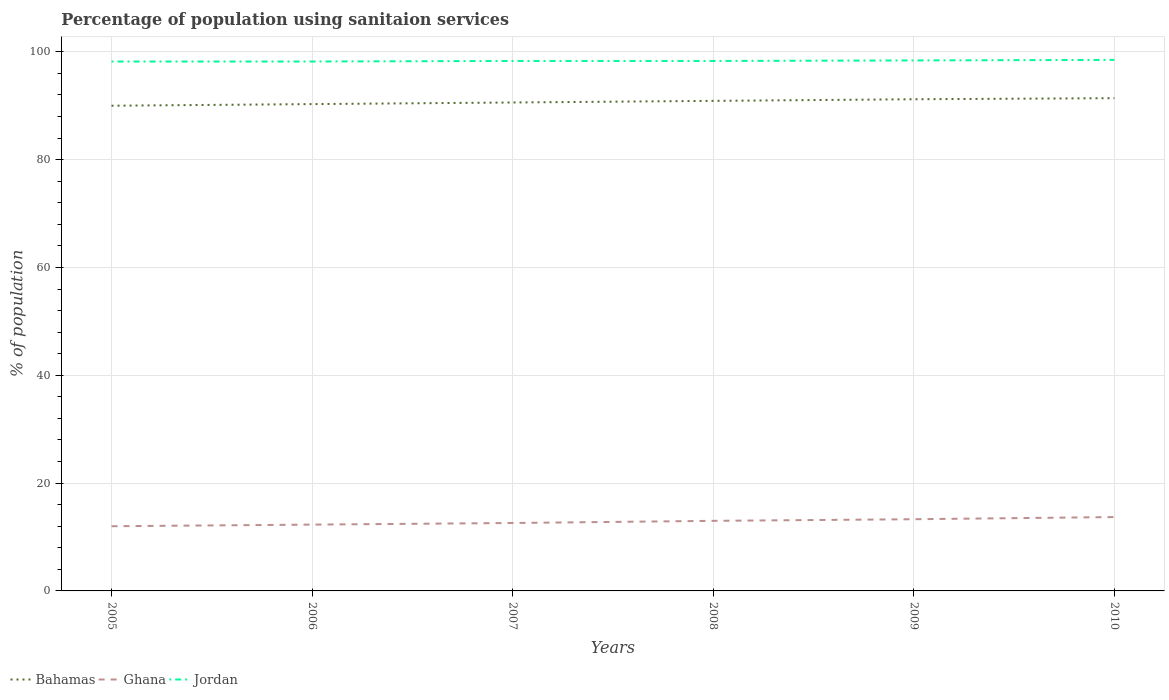Across all years, what is the maximum percentage of population using sanitaion services in Bahamas?
Give a very brief answer. 90. In which year was the percentage of population using sanitaion services in Ghana maximum?
Offer a terse response. 2005. What is the total percentage of population using sanitaion services in Bahamas in the graph?
Your answer should be compact. -0.6. What is the difference between the highest and the second highest percentage of population using sanitaion services in Ghana?
Provide a succinct answer. 1.7. What is the difference between the highest and the lowest percentage of population using sanitaion services in Jordan?
Offer a terse response. 2. Is the percentage of population using sanitaion services in Bahamas strictly greater than the percentage of population using sanitaion services in Ghana over the years?
Offer a terse response. No. What is the difference between two consecutive major ticks on the Y-axis?
Give a very brief answer. 20. Does the graph contain any zero values?
Ensure brevity in your answer.  No. Does the graph contain grids?
Make the answer very short. Yes. Where does the legend appear in the graph?
Your answer should be very brief. Bottom left. What is the title of the graph?
Your response must be concise. Percentage of population using sanitaion services. Does "Fiji" appear as one of the legend labels in the graph?
Ensure brevity in your answer.  No. What is the label or title of the Y-axis?
Your answer should be compact. % of population. What is the % of population of Ghana in 2005?
Offer a very short reply. 12. What is the % of population in Jordan in 2005?
Your answer should be compact. 98.2. What is the % of population of Bahamas in 2006?
Provide a succinct answer. 90.3. What is the % of population in Ghana in 2006?
Offer a terse response. 12.3. What is the % of population of Jordan in 2006?
Your answer should be compact. 98.2. What is the % of population in Bahamas in 2007?
Provide a succinct answer. 90.6. What is the % of population of Ghana in 2007?
Give a very brief answer. 12.6. What is the % of population in Jordan in 2007?
Keep it short and to the point. 98.3. What is the % of population in Bahamas in 2008?
Ensure brevity in your answer.  90.9. What is the % of population in Ghana in 2008?
Keep it short and to the point. 13. What is the % of population of Jordan in 2008?
Make the answer very short. 98.3. What is the % of population of Bahamas in 2009?
Your answer should be compact. 91.2. What is the % of population in Jordan in 2009?
Provide a short and direct response. 98.4. What is the % of population in Bahamas in 2010?
Keep it short and to the point. 91.4. What is the % of population in Jordan in 2010?
Keep it short and to the point. 98.5. Across all years, what is the maximum % of population of Bahamas?
Offer a very short reply. 91.4. Across all years, what is the maximum % of population in Jordan?
Provide a succinct answer. 98.5. Across all years, what is the minimum % of population of Ghana?
Give a very brief answer. 12. Across all years, what is the minimum % of population of Jordan?
Your answer should be very brief. 98.2. What is the total % of population in Bahamas in the graph?
Offer a very short reply. 544.4. What is the total % of population in Ghana in the graph?
Keep it short and to the point. 76.9. What is the total % of population in Jordan in the graph?
Make the answer very short. 589.9. What is the difference between the % of population of Bahamas in 2005 and that in 2006?
Offer a terse response. -0.3. What is the difference between the % of population in Ghana in 2005 and that in 2006?
Your answer should be very brief. -0.3. What is the difference between the % of population of Jordan in 2005 and that in 2006?
Ensure brevity in your answer.  0. What is the difference between the % of population of Bahamas in 2005 and that in 2007?
Provide a short and direct response. -0.6. What is the difference between the % of population of Ghana in 2005 and that in 2007?
Offer a terse response. -0.6. What is the difference between the % of population in Jordan in 2005 and that in 2007?
Your answer should be compact. -0.1. What is the difference between the % of population in Ghana in 2005 and that in 2008?
Ensure brevity in your answer.  -1. What is the difference between the % of population of Jordan in 2005 and that in 2008?
Your answer should be very brief. -0.1. What is the difference between the % of population in Bahamas in 2005 and that in 2009?
Your response must be concise. -1.2. What is the difference between the % of population in Jordan in 2005 and that in 2009?
Provide a succinct answer. -0.2. What is the difference between the % of population in Ghana in 2005 and that in 2010?
Ensure brevity in your answer.  -1.7. What is the difference between the % of population in Jordan in 2005 and that in 2010?
Ensure brevity in your answer.  -0.3. What is the difference between the % of population of Ghana in 2006 and that in 2007?
Offer a terse response. -0.3. What is the difference between the % of population in Jordan in 2006 and that in 2007?
Give a very brief answer. -0.1. What is the difference between the % of population in Jordan in 2006 and that in 2008?
Keep it short and to the point. -0.1. What is the difference between the % of population in Ghana in 2006 and that in 2009?
Provide a succinct answer. -1. What is the difference between the % of population of Ghana in 2006 and that in 2010?
Your answer should be very brief. -1.4. What is the difference between the % of population of Bahamas in 2007 and that in 2008?
Provide a short and direct response. -0.3. What is the difference between the % of population of Jordan in 2007 and that in 2008?
Keep it short and to the point. 0. What is the difference between the % of population of Ghana in 2007 and that in 2009?
Give a very brief answer. -0.7. What is the difference between the % of population of Jordan in 2007 and that in 2009?
Ensure brevity in your answer.  -0.1. What is the difference between the % of population in Jordan in 2008 and that in 2010?
Provide a succinct answer. -0.2. What is the difference between the % of population in Bahamas in 2005 and the % of population in Ghana in 2006?
Your response must be concise. 77.7. What is the difference between the % of population in Bahamas in 2005 and the % of population in Jordan in 2006?
Give a very brief answer. -8.2. What is the difference between the % of population in Ghana in 2005 and the % of population in Jordan in 2006?
Offer a terse response. -86.2. What is the difference between the % of population of Bahamas in 2005 and the % of population of Ghana in 2007?
Give a very brief answer. 77.4. What is the difference between the % of population in Bahamas in 2005 and the % of population in Jordan in 2007?
Make the answer very short. -8.3. What is the difference between the % of population in Ghana in 2005 and the % of population in Jordan in 2007?
Provide a succinct answer. -86.3. What is the difference between the % of population of Ghana in 2005 and the % of population of Jordan in 2008?
Your response must be concise. -86.3. What is the difference between the % of population of Bahamas in 2005 and the % of population of Ghana in 2009?
Give a very brief answer. 76.7. What is the difference between the % of population in Bahamas in 2005 and the % of population in Jordan in 2009?
Offer a very short reply. -8.4. What is the difference between the % of population of Ghana in 2005 and the % of population of Jordan in 2009?
Your answer should be compact. -86.4. What is the difference between the % of population of Bahamas in 2005 and the % of population of Ghana in 2010?
Ensure brevity in your answer.  76.3. What is the difference between the % of population of Bahamas in 2005 and the % of population of Jordan in 2010?
Your response must be concise. -8.5. What is the difference between the % of population in Ghana in 2005 and the % of population in Jordan in 2010?
Offer a very short reply. -86.5. What is the difference between the % of population in Bahamas in 2006 and the % of population in Ghana in 2007?
Offer a terse response. 77.7. What is the difference between the % of population of Bahamas in 2006 and the % of population of Jordan in 2007?
Keep it short and to the point. -8. What is the difference between the % of population of Ghana in 2006 and the % of population of Jordan in 2007?
Make the answer very short. -86. What is the difference between the % of population of Bahamas in 2006 and the % of population of Ghana in 2008?
Your answer should be compact. 77.3. What is the difference between the % of population in Bahamas in 2006 and the % of population in Jordan in 2008?
Your answer should be compact. -8. What is the difference between the % of population of Ghana in 2006 and the % of population of Jordan in 2008?
Provide a short and direct response. -86. What is the difference between the % of population in Bahamas in 2006 and the % of population in Ghana in 2009?
Offer a very short reply. 77. What is the difference between the % of population of Ghana in 2006 and the % of population of Jordan in 2009?
Offer a terse response. -86.1. What is the difference between the % of population of Bahamas in 2006 and the % of population of Ghana in 2010?
Give a very brief answer. 76.6. What is the difference between the % of population in Ghana in 2006 and the % of population in Jordan in 2010?
Provide a short and direct response. -86.2. What is the difference between the % of population of Bahamas in 2007 and the % of population of Ghana in 2008?
Offer a terse response. 77.6. What is the difference between the % of population in Ghana in 2007 and the % of population in Jordan in 2008?
Keep it short and to the point. -85.7. What is the difference between the % of population of Bahamas in 2007 and the % of population of Ghana in 2009?
Your answer should be compact. 77.3. What is the difference between the % of population in Bahamas in 2007 and the % of population in Jordan in 2009?
Your response must be concise. -7.8. What is the difference between the % of population in Ghana in 2007 and the % of population in Jordan in 2009?
Ensure brevity in your answer.  -85.8. What is the difference between the % of population of Bahamas in 2007 and the % of population of Ghana in 2010?
Give a very brief answer. 76.9. What is the difference between the % of population in Bahamas in 2007 and the % of population in Jordan in 2010?
Offer a very short reply. -7.9. What is the difference between the % of population in Ghana in 2007 and the % of population in Jordan in 2010?
Keep it short and to the point. -85.9. What is the difference between the % of population of Bahamas in 2008 and the % of population of Ghana in 2009?
Ensure brevity in your answer.  77.6. What is the difference between the % of population in Ghana in 2008 and the % of population in Jordan in 2009?
Provide a short and direct response. -85.4. What is the difference between the % of population of Bahamas in 2008 and the % of population of Ghana in 2010?
Your response must be concise. 77.2. What is the difference between the % of population of Bahamas in 2008 and the % of population of Jordan in 2010?
Your response must be concise. -7.6. What is the difference between the % of population of Ghana in 2008 and the % of population of Jordan in 2010?
Your response must be concise. -85.5. What is the difference between the % of population in Bahamas in 2009 and the % of population in Ghana in 2010?
Give a very brief answer. 77.5. What is the difference between the % of population of Bahamas in 2009 and the % of population of Jordan in 2010?
Your answer should be compact. -7.3. What is the difference between the % of population in Ghana in 2009 and the % of population in Jordan in 2010?
Keep it short and to the point. -85.2. What is the average % of population in Bahamas per year?
Give a very brief answer. 90.73. What is the average % of population in Ghana per year?
Your answer should be compact. 12.82. What is the average % of population in Jordan per year?
Make the answer very short. 98.32. In the year 2005, what is the difference between the % of population in Bahamas and % of population in Ghana?
Offer a terse response. 78. In the year 2005, what is the difference between the % of population of Bahamas and % of population of Jordan?
Provide a short and direct response. -8.2. In the year 2005, what is the difference between the % of population of Ghana and % of population of Jordan?
Make the answer very short. -86.2. In the year 2006, what is the difference between the % of population in Bahamas and % of population in Ghana?
Your answer should be very brief. 78. In the year 2006, what is the difference between the % of population of Ghana and % of population of Jordan?
Make the answer very short. -85.9. In the year 2007, what is the difference between the % of population of Ghana and % of population of Jordan?
Provide a short and direct response. -85.7. In the year 2008, what is the difference between the % of population of Bahamas and % of population of Ghana?
Make the answer very short. 77.9. In the year 2008, what is the difference between the % of population in Ghana and % of population in Jordan?
Your response must be concise. -85.3. In the year 2009, what is the difference between the % of population in Bahamas and % of population in Ghana?
Ensure brevity in your answer.  77.9. In the year 2009, what is the difference between the % of population in Ghana and % of population in Jordan?
Make the answer very short. -85.1. In the year 2010, what is the difference between the % of population of Bahamas and % of population of Ghana?
Your response must be concise. 77.7. In the year 2010, what is the difference between the % of population in Ghana and % of population in Jordan?
Offer a terse response. -84.8. What is the ratio of the % of population in Bahamas in 2005 to that in 2006?
Give a very brief answer. 1. What is the ratio of the % of population of Ghana in 2005 to that in 2006?
Keep it short and to the point. 0.98. What is the ratio of the % of population in Jordan in 2005 to that in 2006?
Ensure brevity in your answer.  1. What is the ratio of the % of population in Bahamas in 2005 to that in 2007?
Provide a short and direct response. 0.99. What is the ratio of the % of population in Jordan in 2005 to that in 2007?
Your response must be concise. 1. What is the ratio of the % of population in Ghana in 2005 to that in 2009?
Provide a succinct answer. 0.9. What is the ratio of the % of population of Bahamas in 2005 to that in 2010?
Your response must be concise. 0.98. What is the ratio of the % of population in Ghana in 2005 to that in 2010?
Offer a very short reply. 0.88. What is the ratio of the % of population of Jordan in 2005 to that in 2010?
Ensure brevity in your answer.  1. What is the ratio of the % of population in Bahamas in 2006 to that in 2007?
Provide a succinct answer. 1. What is the ratio of the % of population of Ghana in 2006 to that in 2007?
Keep it short and to the point. 0.98. What is the ratio of the % of population of Jordan in 2006 to that in 2007?
Offer a terse response. 1. What is the ratio of the % of population of Ghana in 2006 to that in 2008?
Provide a short and direct response. 0.95. What is the ratio of the % of population of Bahamas in 2006 to that in 2009?
Ensure brevity in your answer.  0.99. What is the ratio of the % of population in Ghana in 2006 to that in 2009?
Make the answer very short. 0.92. What is the ratio of the % of population of Bahamas in 2006 to that in 2010?
Provide a succinct answer. 0.99. What is the ratio of the % of population of Ghana in 2006 to that in 2010?
Ensure brevity in your answer.  0.9. What is the ratio of the % of population of Jordan in 2006 to that in 2010?
Offer a very short reply. 1. What is the ratio of the % of population in Bahamas in 2007 to that in 2008?
Your response must be concise. 1. What is the ratio of the % of population of Ghana in 2007 to that in 2008?
Your answer should be compact. 0.97. What is the ratio of the % of population of Jordan in 2007 to that in 2008?
Ensure brevity in your answer.  1. What is the ratio of the % of population of Bahamas in 2007 to that in 2009?
Offer a very short reply. 0.99. What is the ratio of the % of population in Ghana in 2007 to that in 2009?
Your response must be concise. 0.95. What is the ratio of the % of population in Bahamas in 2007 to that in 2010?
Keep it short and to the point. 0.99. What is the ratio of the % of population in Ghana in 2007 to that in 2010?
Provide a succinct answer. 0.92. What is the ratio of the % of population of Jordan in 2007 to that in 2010?
Keep it short and to the point. 1. What is the ratio of the % of population in Ghana in 2008 to that in 2009?
Offer a very short reply. 0.98. What is the ratio of the % of population of Ghana in 2008 to that in 2010?
Keep it short and to the point. 0.95. What is the ratio of the % of population of Bahamas in 2009 to that in 2010?
Make the answer very short. 1. What is the ratio of the % of population of Ghana in 2009 to that in 2010?
Keep it short and to the point. 0.97. What is the difference between the highest and the second highest % of population in Ghana?
Your answer should be compact. 0.4. What is the difference between the highest and the second highest % of population of Jordan?
Keep it short and to the point. 0.1. What is the difference between the highest and the lowest % of population in Bahamas?
Provide a short and direct response. 1.4. 